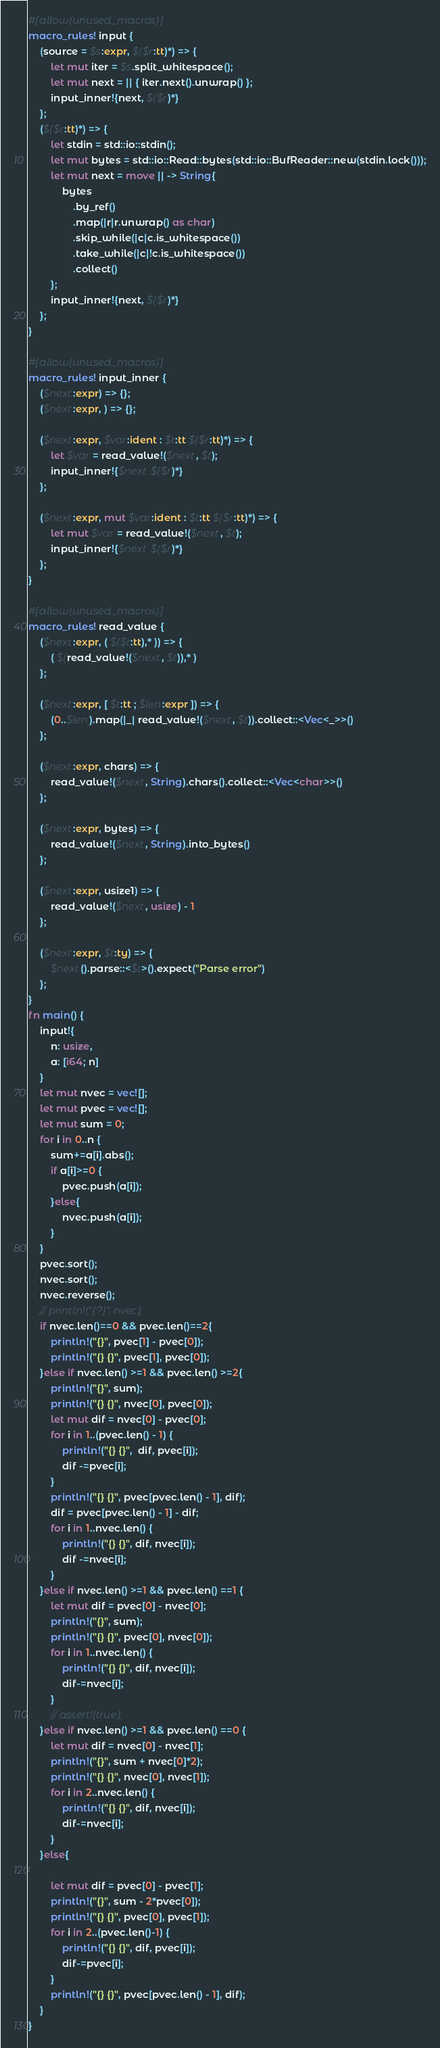<code> <loc_0><loc_0><loc_500><loc_500><_Rust_>#[allow(unused_macros)]
macro_rules! input {
    (source = $s:expr, $($r:tt)*) => {
        let mut iter = $s.split_whitespace();
        let mut next = || { iter.next().unwrap() };
        input_inner!{next, $($r)*}
    };
    ($($r:tt)*) => {
        let stdin = std::io::stdin();
        let mut bytes = std::io::Read::bytes(std::io::BufReader::new(stdin.lock()));
        let mut next = move || -> String{
            bytes
                .by_ref()
                .map(|r|r.unwrap() as char)
                .skip_while(|c|c.is_whitespace())
                .take_while(|c|!c.is_whitespace())
                .collect()
        };
        input_inner!{next, $($r)*}
    };
}

#[allow(unused_macros)]
macro_rules! input_inner {
    ($next:expr) => {};
    ($next:expr, ) => {};

    ($next:expr, $var:ident : $t:tt $($r:tt)*) => {
        let $var = read_value!($next, $t);
        input_inner!{$next $($r)*}
    };

    ($next:expr, mut $var:ident : $t:tt $($r:tt)*) => {
        let mut $var = read_value!($next, $t);
        input_inner!{$next $($r)*}
    };
}

#[allow(unused_macros)]
macro_rules! read_value {
    ($next:expr, ( $($t:tt),* )) => {
        ( $(read_value!($next, $t)),* )
    };

    ($next:expr, [ $t:tt ; $len:expr ]) => {
        (0..$len).map(|_| read_value!($next, $t)).collect::<Vec<_>>()
    };

    ($next:expr, chars) => {
        read_value!($next, String).chars().collect::<Vec<char>>()
    };

    ($next:expr, bytes) => {
        read_value!($next, String).into_bytes()
    };

    ($next:expr, usize1) => {
        read_value!($next, usize) - 1
    };

    ($next:expr, $t:ty) => {
        $next().parse::<$t>().expect("Parse error")
    };
}
fn main() {
    input!{
        n: usize,
        a: [i64; n]
    }
    let mut nvec = vec![];
    let mut pvec = vec![];
    let mut sum = 0;
    for i in 0..n {
        sum+=a[i].abs();
        if a[i]>=0 {
            pvec.push(a[i]);
        }else{
            nvec.push(a[i]);
        }
    }
    pvec.sort();
    nvec.sort();
    nvec.reverse();
    // println!("{:?}", nvec);
    if nvec.len()==0 && pvec.len()==2{
        println!("{}", pvec[1] - pvec[0]);
        println!("{} {}", pvec[1], pvec[0]);
    }else if nvec.len() >=1 && pvec.len() >=2{
        println!("{}", sum);
        println!("{} {}", nvec[0], pvec[0]);
        let mut dif = nvec[0] - pvec[0];
        for i in 1..(pvec.len() - 1) {
            println!("{} {}",  dif, pvec[i]);
            dif -=pvec[i];
        }
        println!("{} {}", pvec[pvec.len() - 1], dif);
        dif = pvec[pvec.len() - 1] - dif;
        for i in 1..nvec.len() {
            println!("{} {}", dif, nvec[i]);
            dif -=nvec[i];
        }
    }else if nvec.len() >=1 && pvec.len() ==1 {
        let mut dif = pvec[0] - nvec[0];
        println!("{}", sum);
        println!("{} {}", pvec[0], nvec[0]);
        for i in 1..nvec.len() {
            println!("{} {}", dif, nvec[i]);
            dif-=nvec[i];
        }
        // assert!(true);
    }else if nvec.len() >=1 && pvec.len() ==0 {
        let mut dif = nvec[0] - nvec[1];
        println!("{}", sum + nvec[0]*2);
        println!("{} {}", nvec[0], nvec[1]);
        for i in 2..nvec.len() {
            println!("{} {}", dif, nvec[i]);
            dif-=nvec[i];
        }
    }else{
        
        let mut dif = pvec[0] - pvec[1];
        println!("{}", sum - 2*pvec[0]);
        println!("{} {}", pvec[0], pvec[1]);
        for i in 2..(pvec.len()-1) {
            println!("{} {}", dif, pvec[i]);
            dif-=pvec[i];
        }
        println!("{} {}", pvec[pvec.len() - 1], dif);
    }
}</code> 